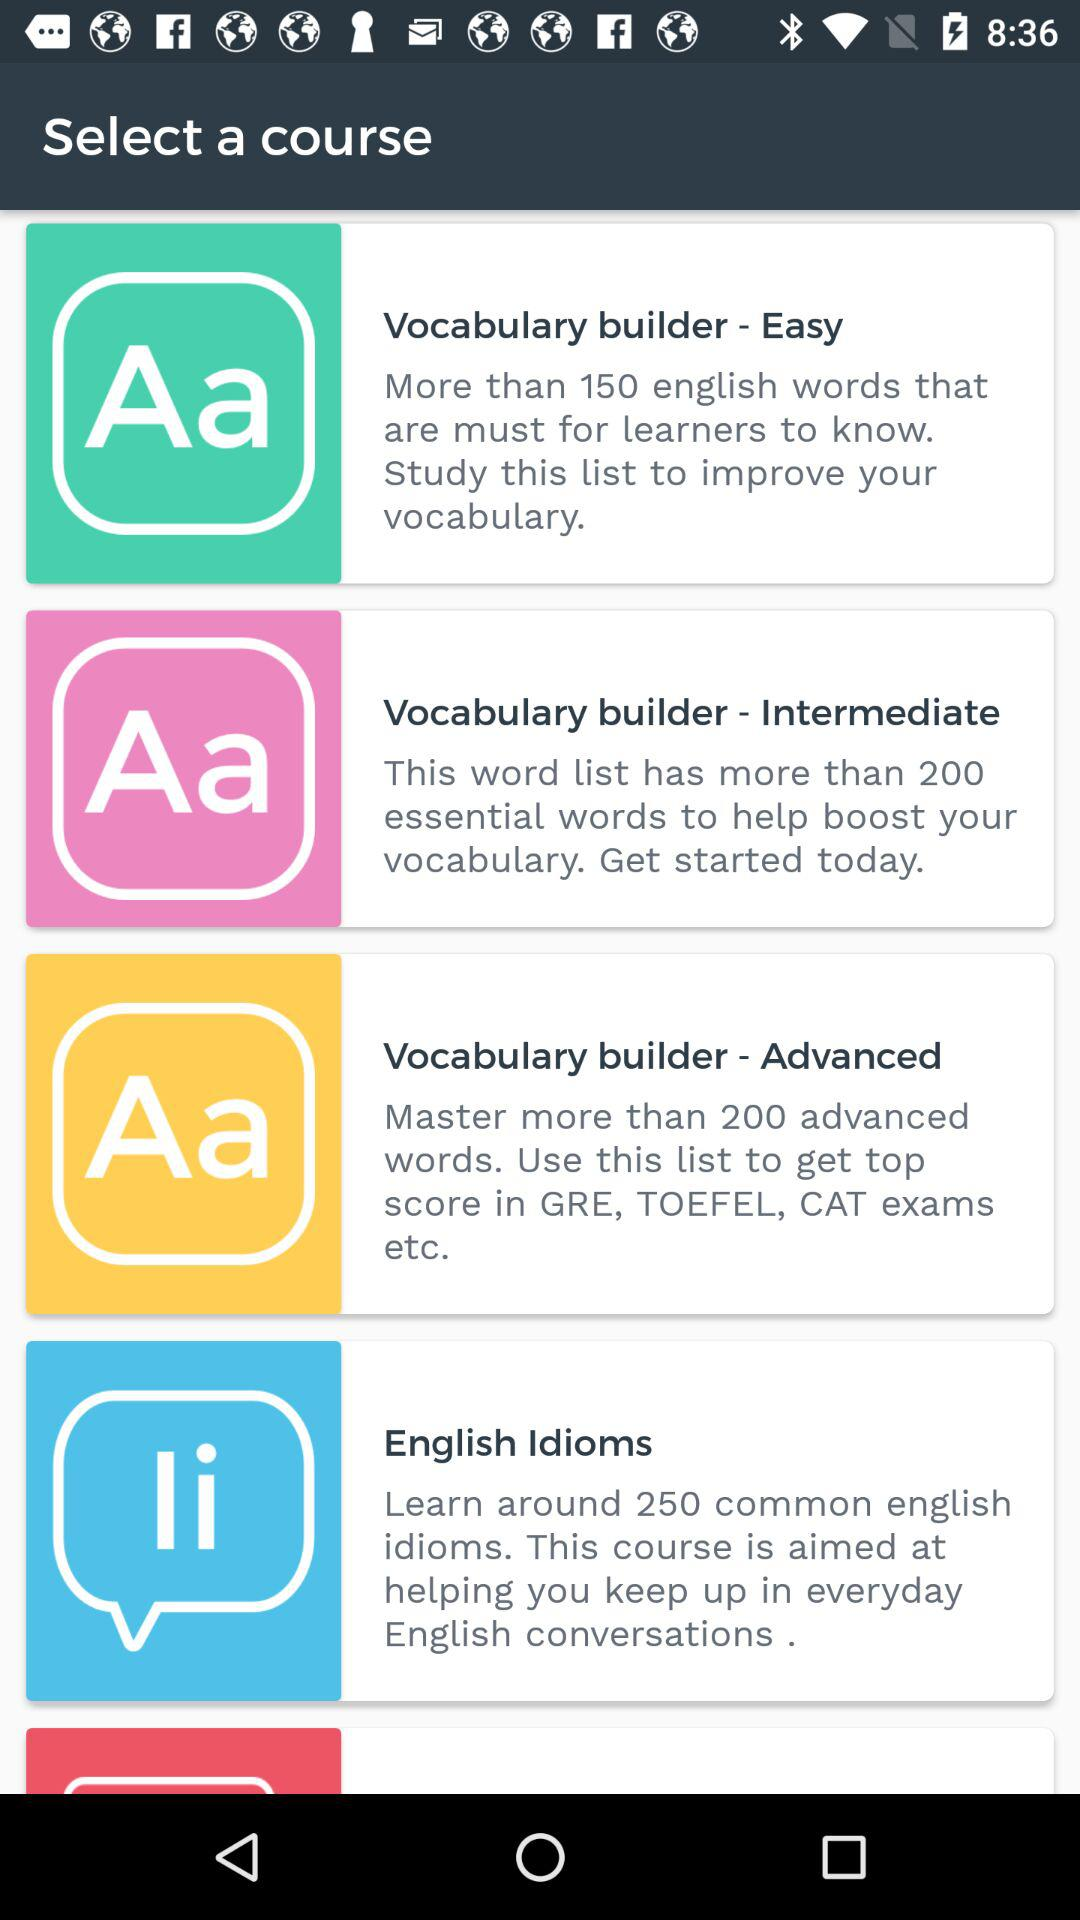What are the names of the available courses? The names of the available courses are "Vocabulary builder - Easy", "Vocabulary builder - Intermediate", "Vocabulary builder - Advanced" and "English Idioms". 